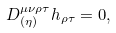Convert formula to latex. <formula><loc_0><loc_0><loc_500><loc_500>D ^ { \mu \nu \rho \tau } _ { ( \eta ) } h _ { \rho \tau } = 0 ,</formula> 